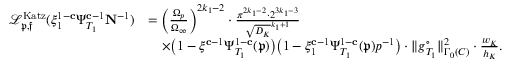<formula> <loc_0><loc_0><loc_500><loc_500>\begin{array} { r l } { { \mathcal { L } } _ { \mathfrak { p } , \mathfrak { f } } ^ { K a t z } ( \xi _ { 1 } ^ { 1 - c } \Psi _ { T _ { 1 } } ^ { c - 1 } N ^ { - 1 } ) } & { = \left ( \frac { \Omega _ { p } } { \Omega _ { \infty } } \right ) ^ { 2 k _ { 1 } - 2 } \cdot \frac { \pi ^ { 2 k _ { 1 } - 2 } \cdot 2 ^ { 3 k _ { 1 } - 3 } } { \sqrt { D _ { K } } ^ { k _ { 1 } + 1 } } } \\ & { \quad \times \left ( 1 - \xi ^ { c - 1 } \Psi _ { T _ { 1 } } ^ { 1 - c } ( \mathfrak { p } ) \right ) \left ( 1 - \xi _ { 1 } ^ { c - 1 } \Psi _ { T _ { 1 } } ^ { 1 - c } ( \mathfrak { p } ) p ^ { - 1 } \right ) \cdot \| { g } _ { T _ { 1 } } ^ { \circ } \| _ { \Gamma _ { 0 } ( C ) } ^ { 2 } \cdot \frac { w _ { K } } { h _ { K } } . } \end{array}</formula> 